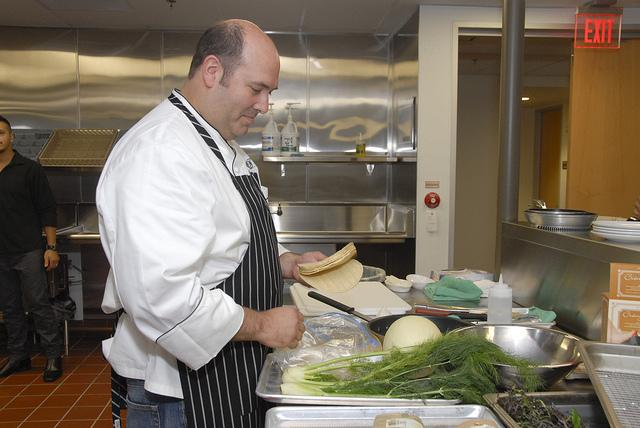What type of wrapper is he putting food in?

Choices:
A) tortilla
B) bun
C) lettuce wrap
D) sliced bread tortilla 